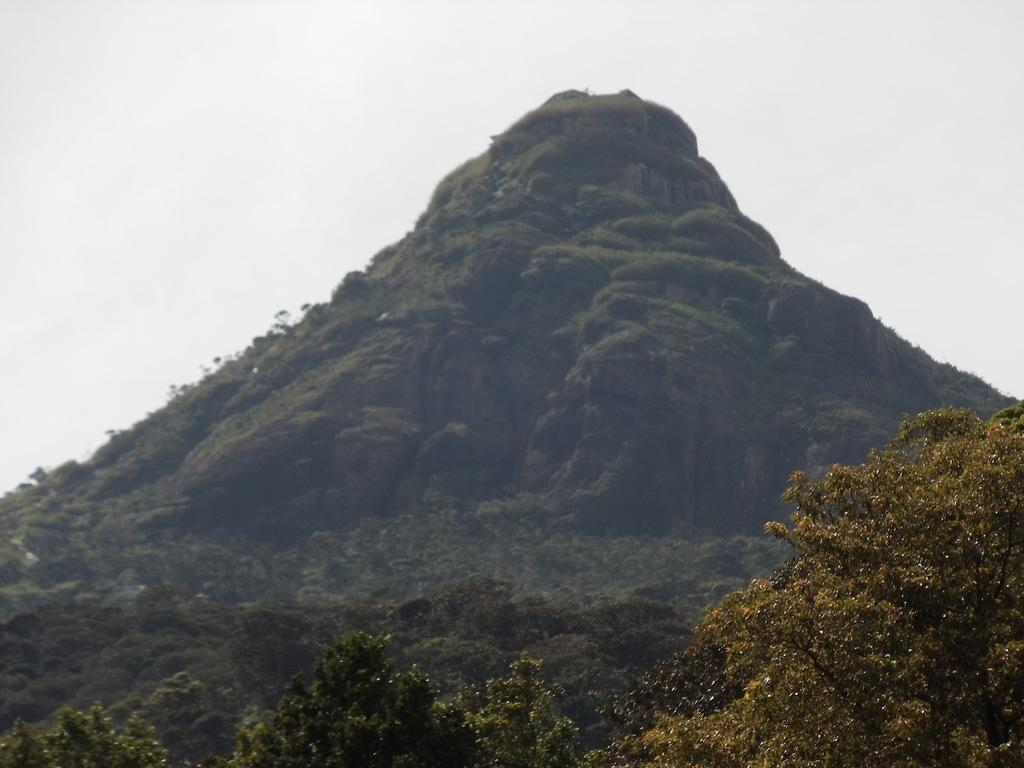What is the main feature in the center of the image? There is a mountain in the center of the image. What type of vegetation can be seen in the image? There are trees in the image. How many boys are visible in the image? There are no boys present in the image; it features a mountain and trees. What type of calendar is hanging on the tree in the image? There is no calendar present in the image; it only features a mountain and trees. 